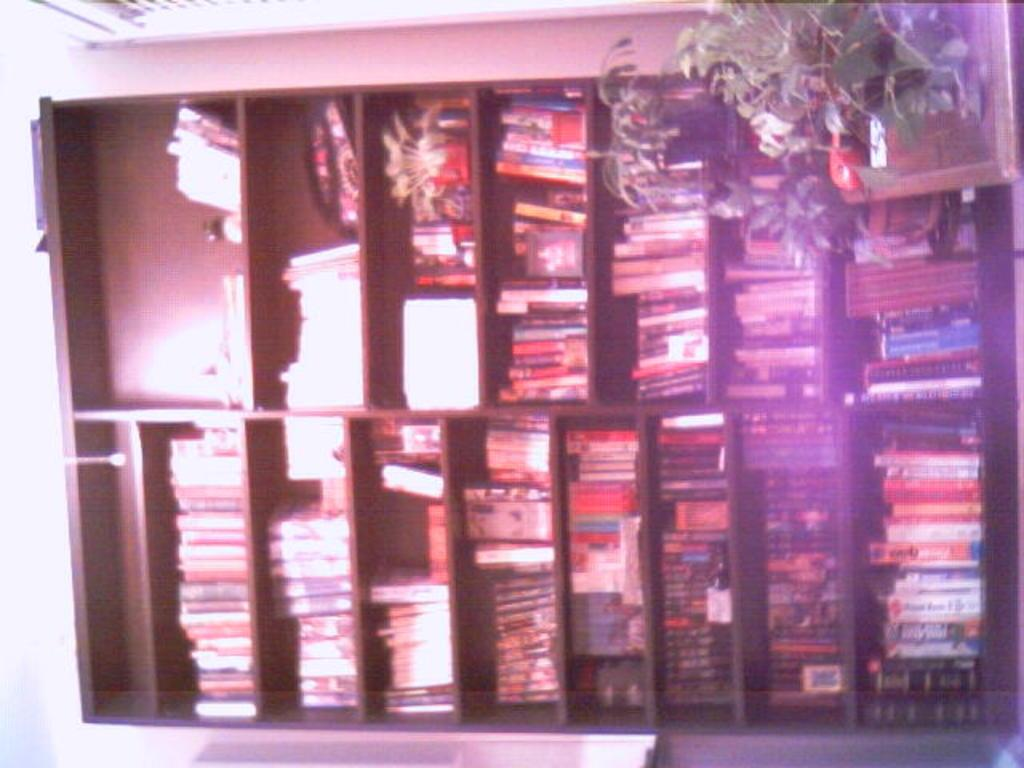What is present on the shelf in the image? There is a shelf in the image, and it has books on it. Are there any other items on the shelf besides books? Yes, there are other objects on the shelf. What else can be seen in the image besides the shelf and its contents? There are plants in the image. What type of fork can be seen being used to plough the plants in the image? There is no fork or plough present in the image, and the plants are not being ploughed. What sound do the bells make in the image? There are no bells present in the image, so it is not possible to determine the sound they might make. 